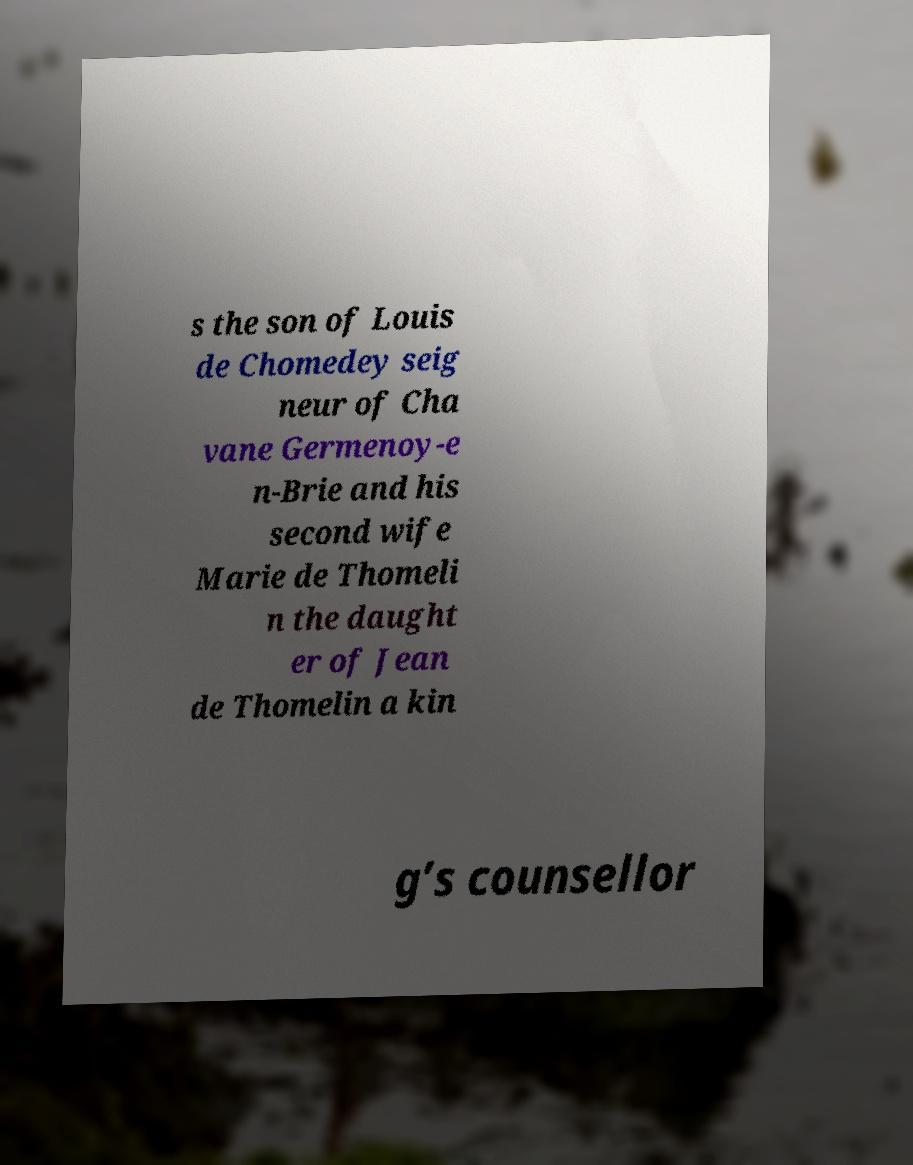Could you assist in decoding the text presented in this image and type it out clearly? s the son of Louis de Chomedey seig neur of Cha vane Germenoy-e n-Brie and his second wife Marie de Thomeli n the daught er of Jean de Thomelin a kin g’s counsellor 